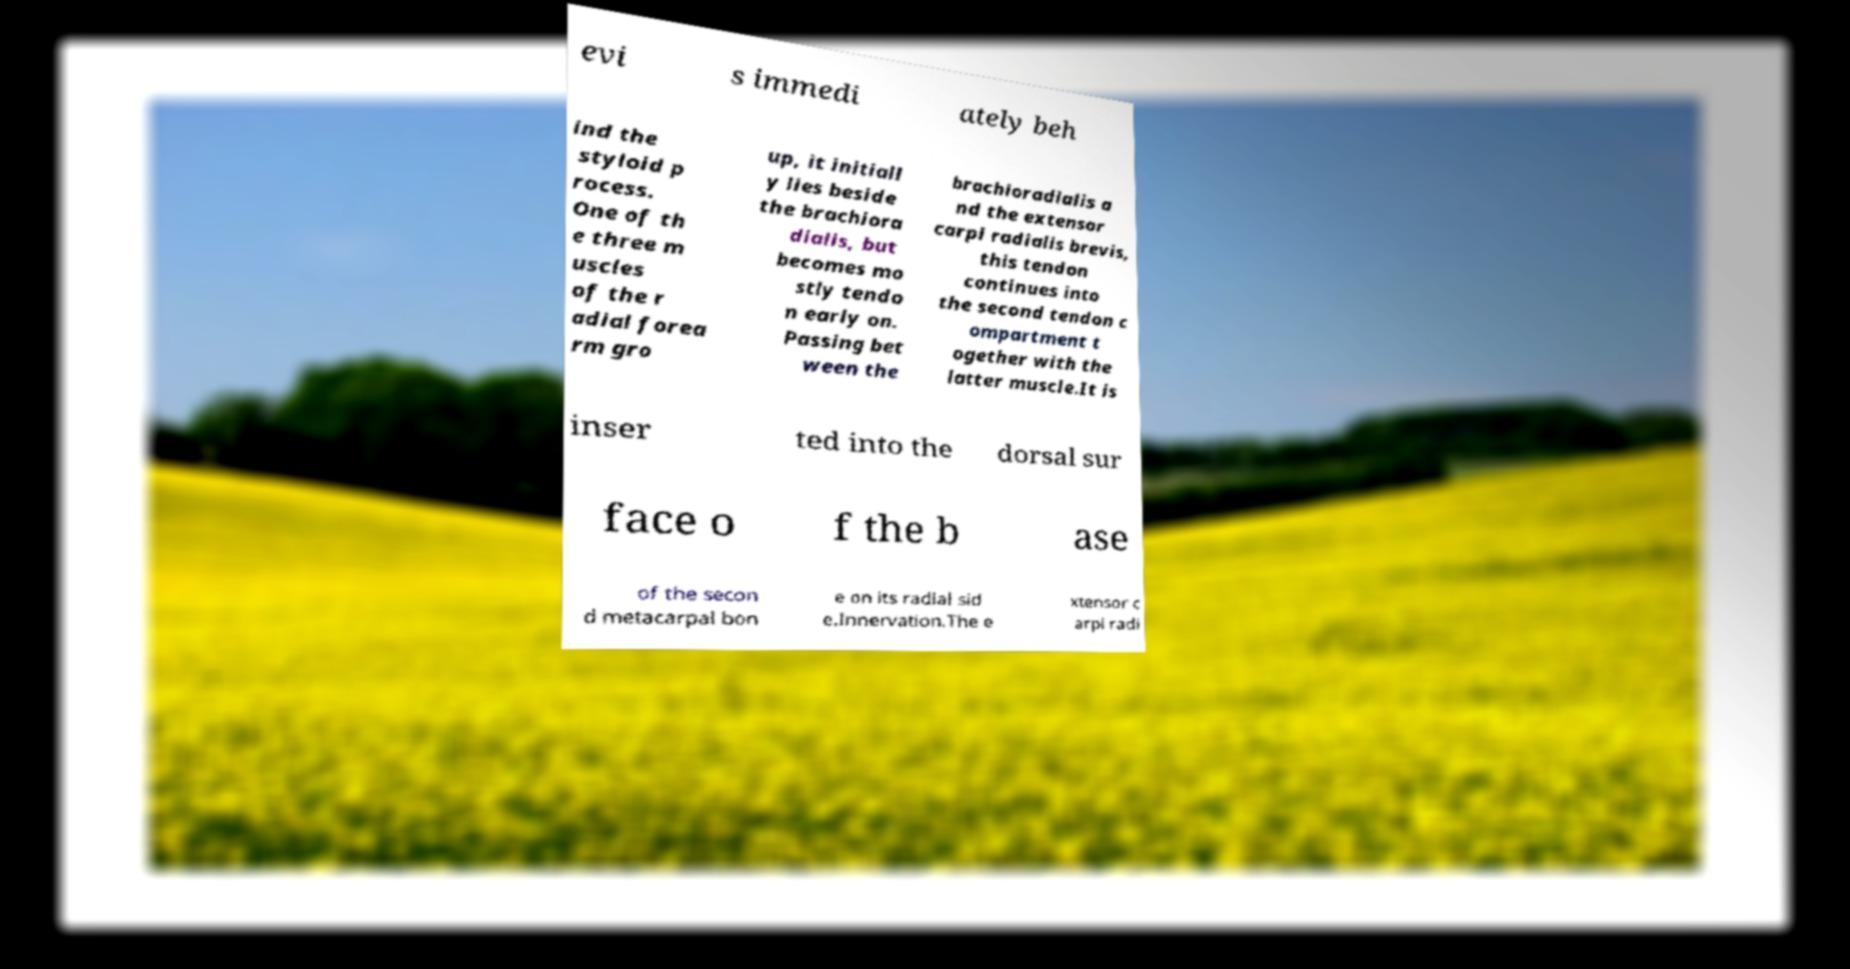Can you read and provide the text displayed in the image?This photo seems to have some interesting text. Can you extract and type it out for me? evi s immedi ately beh ind the styloid p rocess. One of th e three m uscles of the r adial forea rm gro up, it initiall y lies beside the brachiora dialis, but becomes mo stly tendo n early on. Passing bet ween the brachioradialis a nd the extensor carpi radialis brevis, this tendon continues into the second tendon c ompartment t ogether with the latter muscle.It is inser ted into the dorsal sur face o f the b ase of the secon d metacarpal bon e on its radial sid e.Innervation.The e xtensor c arpi radi 